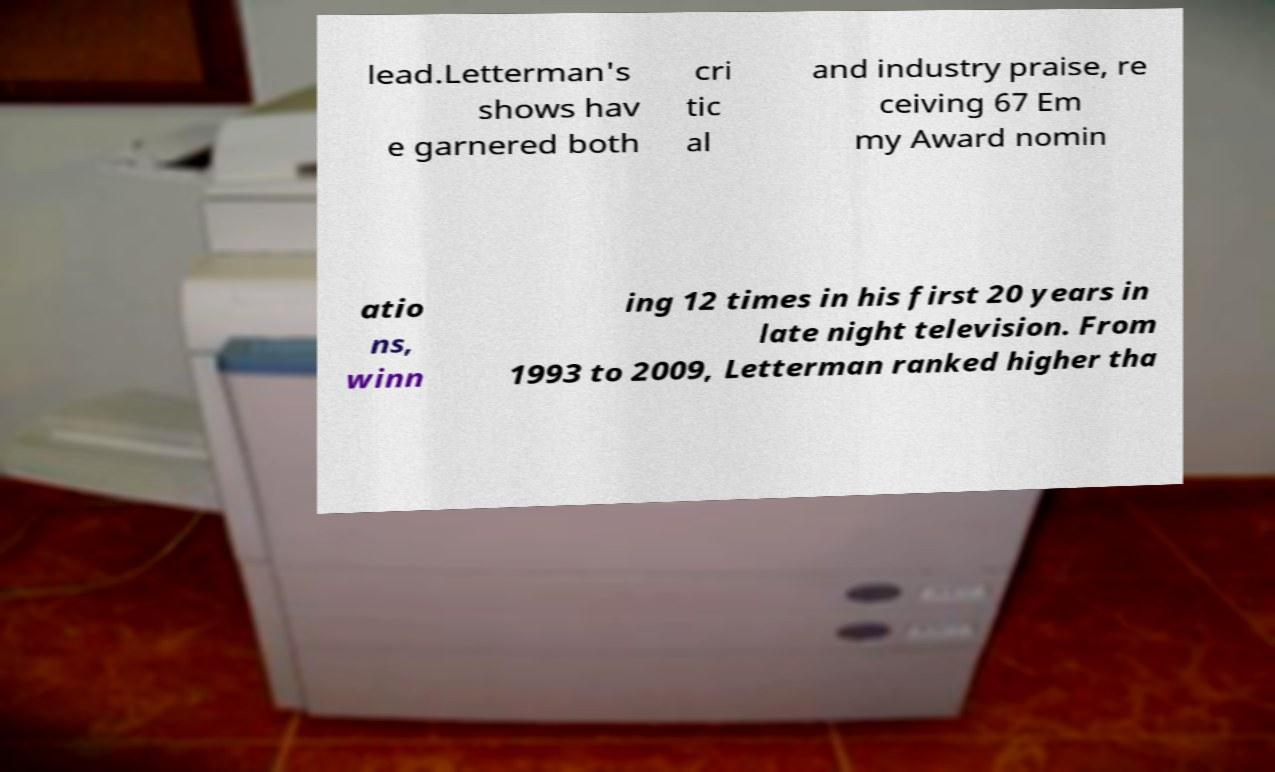Please read and relay the text visible in this image. What does it say? lead.Letterman's shows hav e garnered both cri tic al and industry praise, re ceiving 67 Em my Award nomin atio ns, winn ing 12 times in his first 20 years in late night television. From 1993 to 2009, Letterman ranked higher tha 